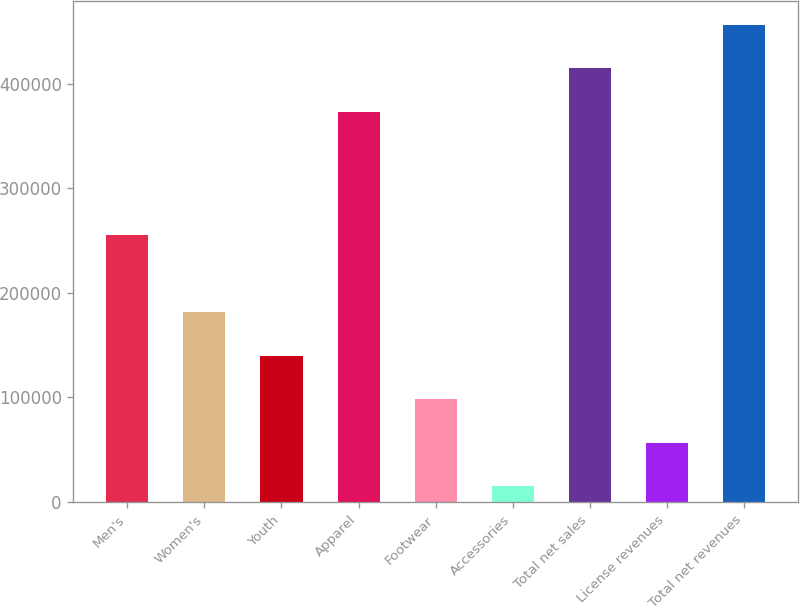Convert chart to OTSL. <chart><loc_0><loc_0><loc_500><loc_500><bar_chart><fcel>Men's<fcel>Women's<fcel>Youth<fcel>Apparel<fcel>Footwear<fcel>Accessories<fcel>Total net sales<fcel>License revenues<fcel>Total net revenues<nl><fcel>255681<fcel>181214<fcel>139635<fcel>373221<fcel>98055.4<fcel>14897<fcel>414992<fcel>56476.2<fcel>456571<nl></chart> 